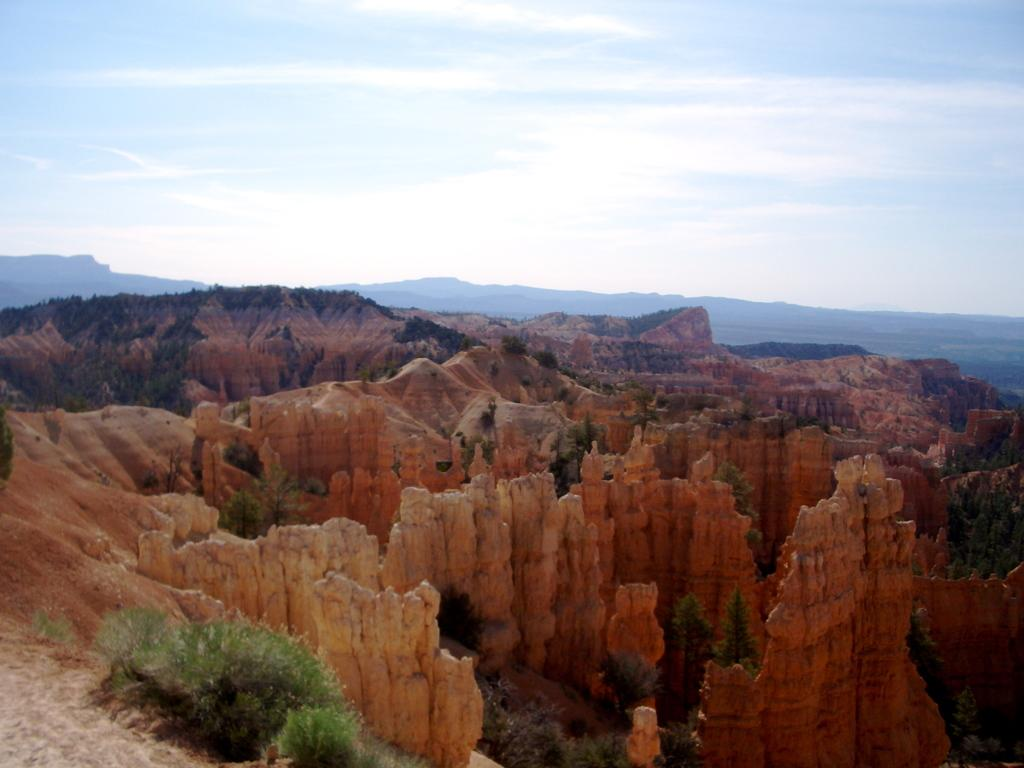What type of terrain is visible in the image? There are red dunes in the image. What other natural elements can be seen in the image? There are trees and plants visible in the image. What is visible in the background of the image? There are mountains and the sky in the background of the image. What can be seen in the sky? Clouds are present in the sky. What type of nail is being used to rub the trees in the image? There is no nail or rubbing action present in the image; it features red dunes, trees, plants, mountains, and a sky with clouds. 